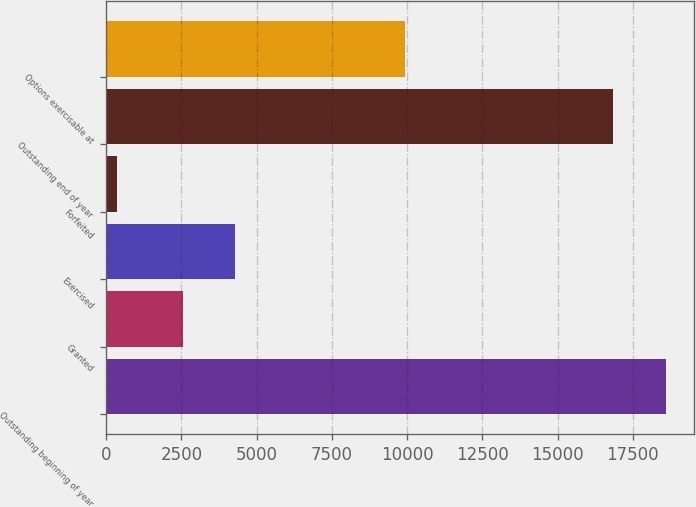Convert chart to OTSL. <chart><loc_0><loc_0><loc_500><loc_500><bar_chart><fcel>Outstanding beginning of year<fcel>Granted<fcel>Exercised<fcel>Forfeited<fcel>Outstanding end of year<fcel>Options exercisable at<nl><fcel>18594.3<fcel>2543<fcel>4287.3<fcel>359<fcel>16850<fcel>9937<nl></chart> 